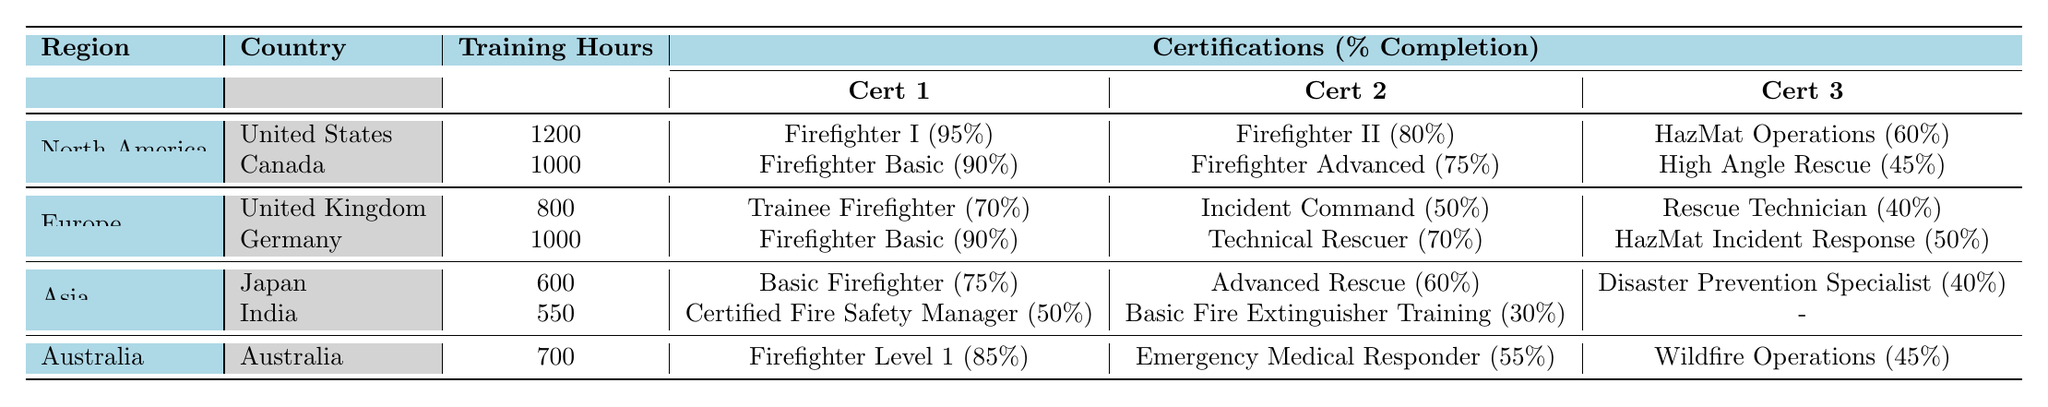What is the total number of training hours for firefighters in North America? The table shows 1200 training hours for the United States and 1000 for Canada. Summing these values gives 1200 + 1000 = 2200 training hours in North America.
Answer: 2200 Which country has the highest percentage completion for firefighting certifications? The highest completion percentage from the table is 95% for Firefighter I in the United States. No other country has a certification above this percentage.
Answer: United States What percentage completion does Germany have for Technical Rescuer certification? The table indicates that Germany has a 70% completion for the Technical Rescuer certification.
Answer: 70% Does Japan have more training hours than India? The table states that Japan has 600 training hours and India has 550 training hours, meaning Japan has more training hours than India.
Answer: Yes What is the average percentage completion of the certifications in Australia? The certifications in Australia have completion percentages of 85%, 55%, and 45%. Summing these gives 85 + 55 + 45 = 185, and averaging them over 3 certifications gives 185 / 3 ≈ 61.67%.
Answer: Approximately 61.67% Are there any certifications in India that complete above 50%? From the table, India's certifications complete at 50% and 30%, meaning none exceed 50%.
Answer: No What is the difference in training hours between North America and Asia? North America has 2200 training hours (from the previous question) and Asia has 600 + 550 = 1150 training hours. The difference is 2200 - 1150 = 1050 training hours.
Answer: 1050 What percentage completion does the United Kingdom have for its lowest rated certification? The United Kingdom's lowest certification percentage completion is 40% for Rescue Technician.
Answer: 40% Which region has the lowest overall training hours for firefighters? The total training hours for each region are: North America (2200), Europe (800 + 1000 = 1800), Asia (600 + 550 = 1150), and Australia (700). The lowest total is for Asia at 1150 hours.
Answer: Asia If we combine the certifications for Germany and the United Kingdom, what is the total percentage completion for all certifications? Germany has completion percentages of 90%, 70%, and 50%, while the UK has 70%, 50%, and 40%. The total is 90 + 70 + 50 + 70 + 50 + 40 = 370%, and with 6 certifications, the average is 370 / 6 = 61.67%.
Answer: Approximately 61.67% 